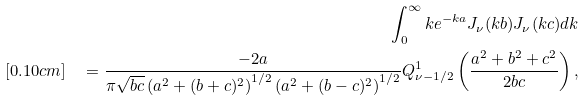Convert formula to latex. <formula><loc_0><loc_0><loc_500><loc_500>\int _ { 0 } ^ { \infty } k e ^ { - k a } J _ { \nu } ( k b ) J _ { \nu } ( k c ) d k \\ [ 0 . 1 0 c m ] \quad = \frac { - 2 a } { \pi \sqrt { b c } \left ( a ^ { 2 } + ( b + c ) ^ { 2 } \right ) ^ { 1 / 2 } \left ( a ^ { 2 } + ( b - c ) ^ { 2 } \right ) ^ { 1 / 2 } } Q _ { \nu - 1 / 2 } ^ { 1 } \left ( \frac { a ^ { 2 } + b ^ { 2 } + c ^ { 2 } } { 2 b c } \right ) ,</formula> 